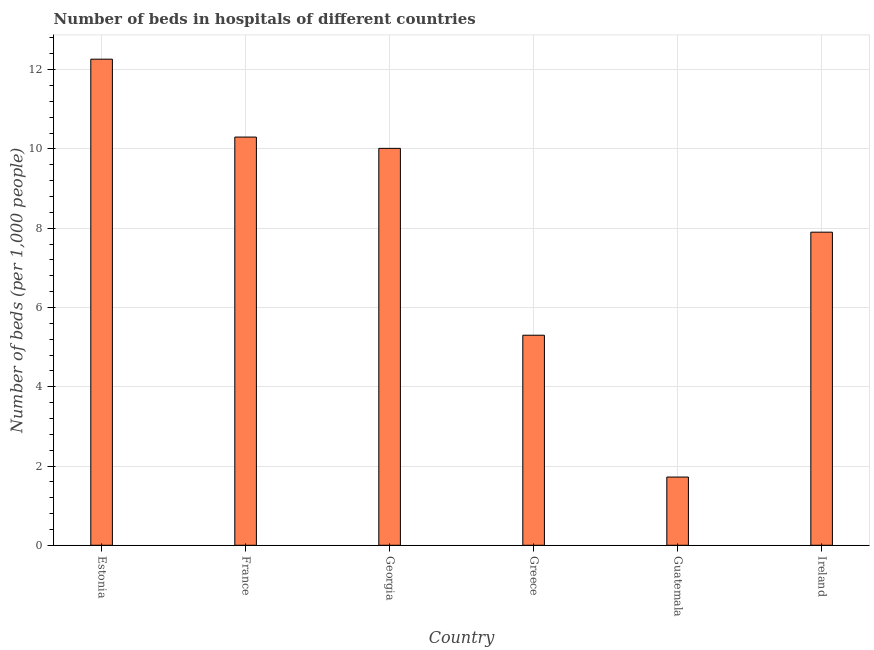Does the graph contain any zero values?
Your response must be concise. No. What is the title of the graph?
Provide a succinct answer. Number of beds in hospitals of different countries. What is the label or title of the X-axis?
Provide a succinct answer. Country. What is the label or title of the Y-axis?
Your answer should be compact. Number of beds (per 1,0 people). What is the number of hospital beds in Ireland?
Keep it short and to the point. 7.9. Across all countries, what is the maximum number of hospital beds?
Keep it short and to the point. 12.27. Across all countries, what is the minimum number of hospital beds?
Keep it short and to the point. 1.72. In which country was the number of hospital beds maximum?
Make the answer very short. Estonia. In which country was the number of hospital beds minimum?
Offer a very short reply. Guatemala. What is the sum of the number of hospital beds?
Offer a very short reply. 47.5. What is the difference between the number of hospital beds in Guatemala and Ireland?
Your answer should be compact. -6.18. What is the average number of hospital beds per country?
Ensure brevity in your answer.  7.92. What is the median number of hospital beds?
Keep it short and to the point. 8.96. What is the ratio of the number of hospital beds in France to that in Greece?
Your answer should be compact. 1.94. Is the number of hospital beds in Estonia less than that in Georgia?
Give a very brief answer. No. What is the difference between the highest and the second highest number of hospital beds?
Ensure brevity in your answer.  1.97. Is the sum of the number of hospital beds in Greece and Ireland greater than the maximum number of hospital beds across all countries?
Keep it short and to the point. Yes. What is the difference between the highest and the lowest number of hospital beds?
Give a very brief answer. 10.54. In how many countries, is the number of hospital beds greater than the average number of hospital beds taken over all countries?
Make the answer very short. 3. How many bars are there?
Ensure brevity in your answer.  6. Are all the bars in the graph horizontal?
Ensure brevity in your answer.  No. How many countries are there in the graph?
Your answer should be very brief. 6. What is the difference between two consecutive major ticks on the Y-axis?
Give a very brief answer. 2. What is the Number of beds (per 1,000 people) in Estonia?
Offer a terse response. 12.27. What is the Number of beds (per 1,000 people) of France?
Offer a terse response. 10.3. What is the Number of beds (per 1,000 people) in Georgia?
Make the answer very short. 10.02. What is the Number of beds (per 1,000 people) of Greece?
Ensure brevity in your answer.  5.3. What is the Number of beds (per 1,000 people) in Guatemala?
Ensure brevity in your answer.  1.72. What is the Number of beds (per 1,000 people) in Ireland?
Your response must be concise. 7.9. What is the difference between the Number of beds (per 1,000 people) in Estonia and France?
Offer a terse response. 1.97. What is the difference between the Number of beds (per 1,000 people) in Estonia and Georgia?
Keep it short and to the point. 2.25. What is the difference between the Number of beds (per 1,000 people) in Estonia and Greece?
Ensure brevity in your answer.  6.97. What is the difference between the Number of beds (per 1,000 people) in Estonia and Guatemala?
Provide a succinct answer. 10.54. What is the difference between the Number of beds (per 1,000 people) in Estonia and Ireland?
Your response must be concise. 4.37. What is the difference between the Number of beds (per 1,000 people) in France and Georgia?
Keep it short and to the point. 0.28. What is the difference between the Number of beds (per 1,000 people) in France and Greece?
Your answer should be very brief. 5. What is the difference between the Number of beds (per 1,000 people) in France and Guatemala?
Offer a terse response. 8.58. What is the difference between the Number of beds (per 1,000 people) in France and Ireland?
Make the answer very short. 2.4. What is the difference between the Number of beds (per 1,000 people) in Georgia and Greece?
Keep it short and to the point. 4.71. What is the difference between the Number of beds (per 1,000 people) in Georgia and Guatemala?
Your answer should be very brief. 8.29. What is the difference between the Number of beds (per 1,000 people) in Georgia and Ireland?
Offer a very short reply. 2.12. What is the difference between the Number of beds (per 1,000 people) in Greece and Guatemala?
Your answer should be very brief. 3.58. What is the difference between the Number of beds (per 1,000 people) in Guatemala and Ireland?
Provide a succinct answer. -6.18. What is the ratio of the Number of beds (per 1,000 people) in Estonia to that in France?
Keep it short and to the point. 1.19. What is the ratio of the Number of beds (per 1,000 people) in Estonia to that in Georgia?
Your response must be concise. 1.23. What is the ratio of the Number of beds (per 1,000 people) in Estonia to that in Greece?
Offer a terse response. 2.31. What is the ratio of the Number of beds (per 1,000 people) in Estonia to that in Guatemala?
Give a very brief answer. 7.13. What is the ratio of the Number of beds (per 1,000 people) in Estonia to that in Ireland?
Offer a terse response. 1.55. What is the ratio of the Number of beds (per 1,000 people) in France to that in Georgia?
Offer a terse response. 1.03. What is the ratio of the Number of beds (per 1,000 people) in France to that in Greece?
Ensure brevity in your answer.  1.94. What is the ratio of the Number of beds (per 1,000 people) in France to that in Guatemala?
Give a very brief answer. 5.98. What is the ratio of the Number of beds (per 1,000 people) in France to that in Ireland?
Give a very brief answer. 1.3. What is the ratio of the Number of beds (per 1,000 people) in Georgia to that in Greece?
Your response must be concise. 1.89. What is the ratio of the Number of beds (per 1,000 people) in Georgia to that in Guatemala?
Your response must be concise. 5.82. What is the ratio of the Number of beds (per 1,000 people) in Georgia to that in Ireland?
Make the answer very short. 1.27. What is the ratio of the Number of beds (per 1,000 people) in Greece to that in Guatemala?
Offer a very short reply. 3.08. What is the ratio of the Number of beds (per 1,000 people) in Greece to that in Ireland?
Make the answer very short. 0.67. What is the ratio of the Number of beds (per 1,000 people) in Guatemala to that in Ireland?
Your answer should be compact. 0.22. 